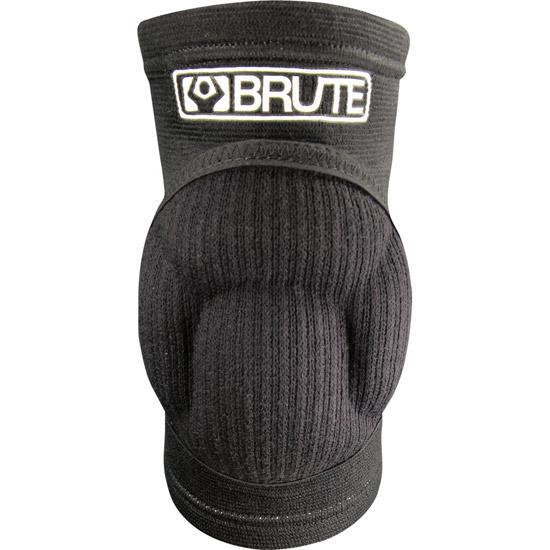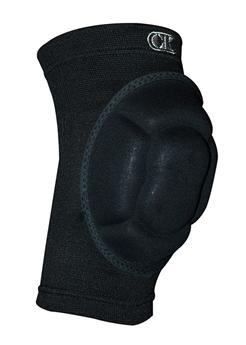The first image is the image on the left, the second image is the image on the right. For the images shown, is this caption "The item in the image on the left is facing forward." true? Answer yes or no. Yes. 